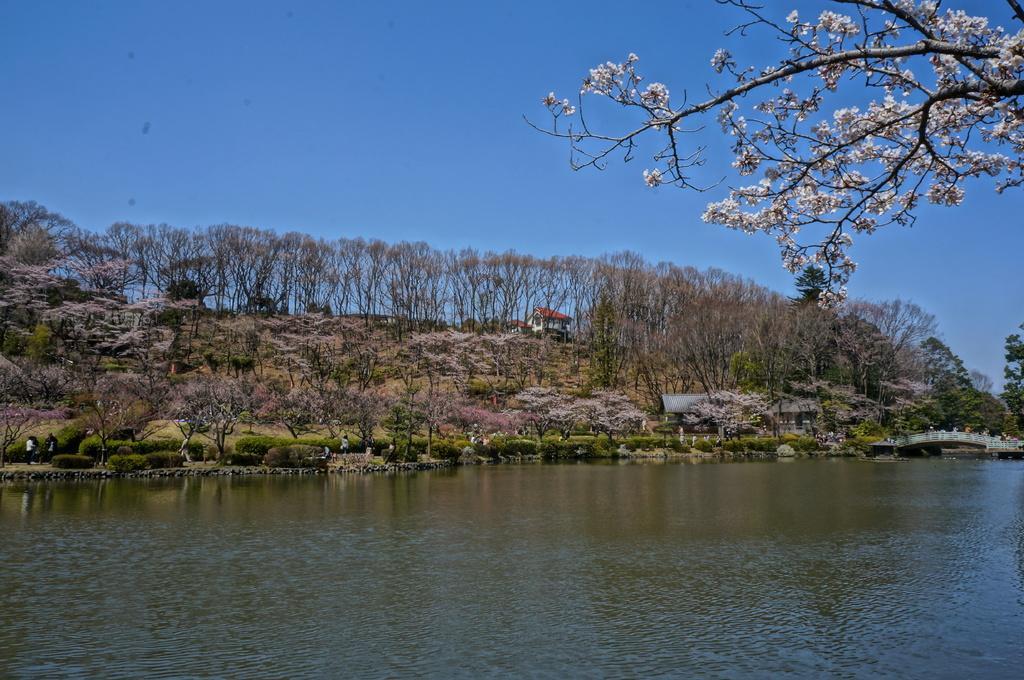Please provide a concise description of this image. In this image I can see the water, the ground, few plants, few trees and few persons standing on the ground. In the background I can see few buildings, few trees, few flowers which are white in color and the sky. 